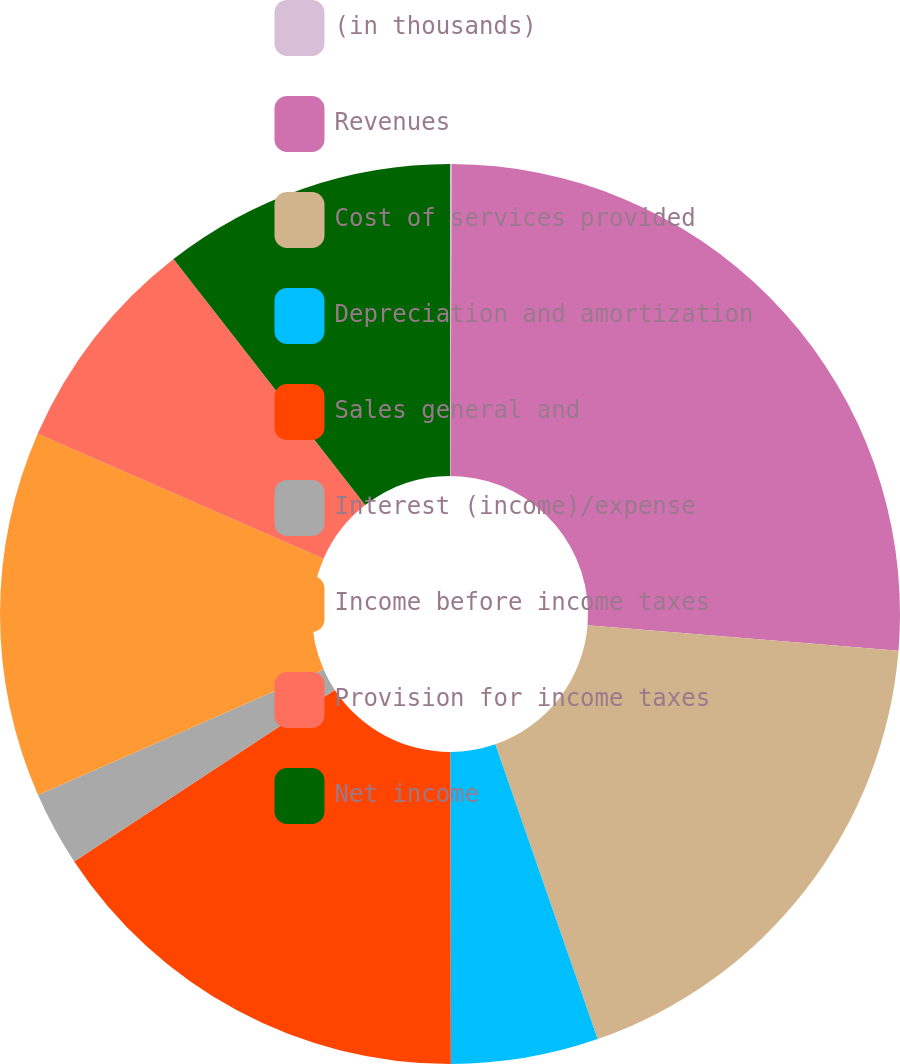Convert chart to OTSL. <chart><loc_0><loc_0><loc_500><loc_500><pie_chart><fcel>(in thousands)<fcel>Revenues<fcel>Cost of services provided<fcel>Depreciation and amortization<fcel>Sales general and<fcel>Interest (income)/expense<fcel>Income before income taxes<fcel>Provision for income taxes<fcel>Net income<nl><fcel>0.06%<fcel>26.24%<fcel>18.38%<fcel>5.29%<fcel>15.76%<fcel>2.68%<fcel>13.15%<fcel>7.91%<fcel>10.53%<nl></chart> 